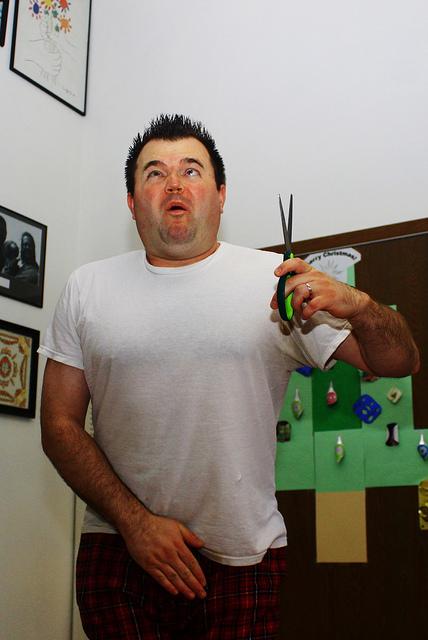What color is the wall?
Be succinct. White. What is the man holding in his hand?
Short answer required. Scissors. What are these scissors used for?
Keep it brief. Cutting. What is the popular name for this man's haircut?
Short answer required. Crew cut. Does the man have a beard?
Short answer required. No. What color is the board?
Short answer required. Brown. What is this person holding?
Keep it brief. Scissors. What is the person wearing?
Concise answer only. T shirt. What color are his pants?
Be succinct. Red. Is that person in pain?
Quick response, please. Yes. Is there an electrical outlet on the wall?
Give a very brief answer. No. 